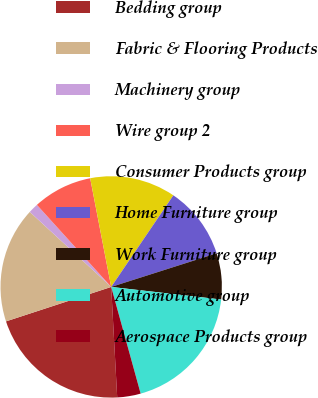<chart> <loc_0><loc_0><loc_500><loc_500><pie_chart><fcel>Bedding group<fcel>Fabric & Flooring Products<fcel>Machinery group<fcel>Wire group 2<fcel>Consumer Products group<fcel>Home Furniture group<fcel>Work Furniture group<fcel>Automotive group<fcel>Aerospace Products group<nl><fcel>20.83%<fcel>16.89%<fcel>1.44%<fcel>8.67%<fcel>12.53%<fcel>10.6%<fcel>6.73%<fcel>18.9%<fcel>3.42%<nl></chart> 